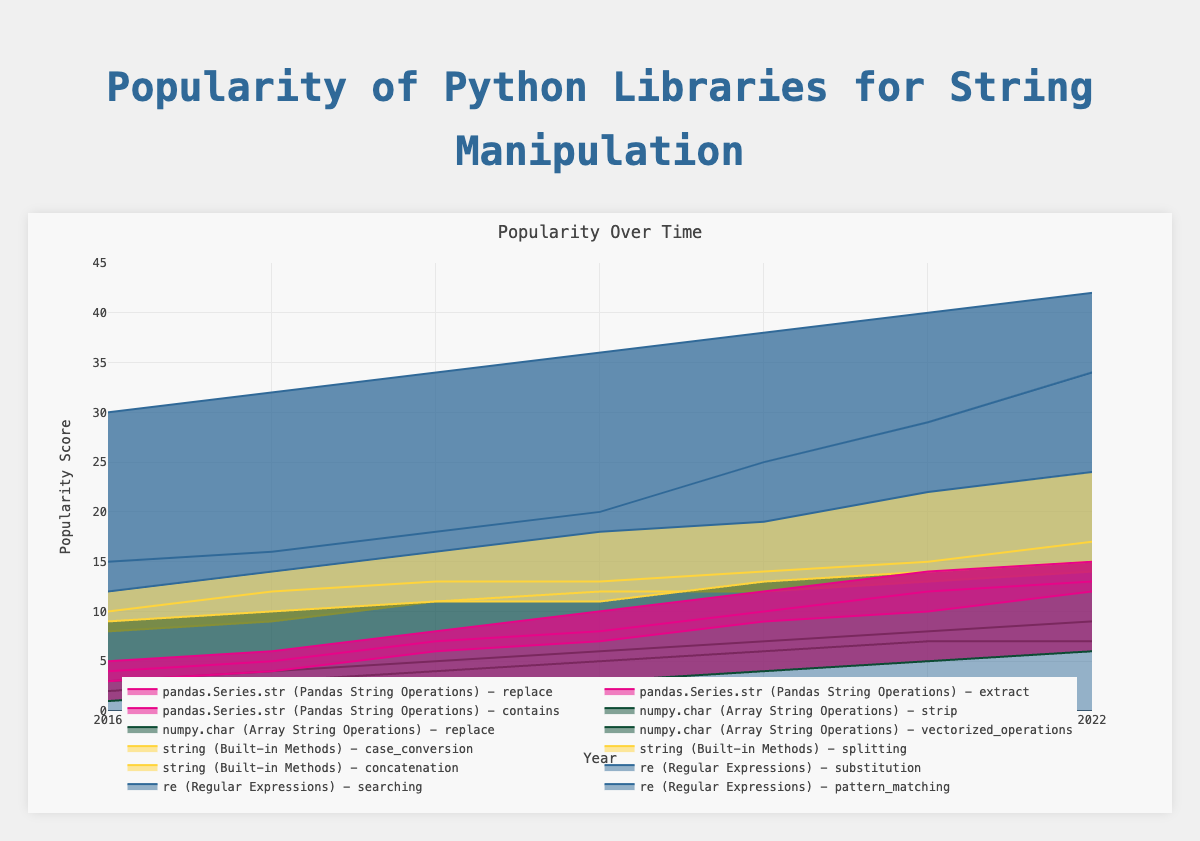What is the title of the chart? The title is prominently displayed at the top of the chart and reads "Popularity Over Time."
Answer: Popularity Over Time Which library function for 're (Regular Expressions)' has the highest popularity score in 2022? By examining the Y-axis values for 2022, we can see that 'pattern_matching' reaches a value of 42, which is higher than other 're (Regular Expressions)' functions.
Answer: pattern_matching What are the axis titles of the chart? The X-axis title is "Year" and the Y-axis title is "Popularity Score," as indicated below the respective axes.
Answer: "Year" and "Popularity Score" In which year did 'pandas.Series.str (Pandas String Operations) - extract' reach a popularity score of 10? By locating the line corresponding to 'pandas.Series.str - extract' and tracing it to the year where it reaches a score of 10, we determine that this occurs in 2020.
Answer: 2020 How much did the popularity score for 'string (Built-in Methods) - concatenation' increase from 2016 to 2022? The popularity score for 'concatenation' in 2016 is 10 and rises to 17 in 2022, resulting in an increase of 17 - 10 = 7.
Answer: 7 Compare the popularity of 'numpy.char - vectorized_operations' and 'pandas.Series.str - contains' in 2018. Which one is more popular and by how much? In 2018, 'numpy.char - vectorized_operations' has a score of 5, while 'pandas.Series.str - contains' has a score of 8. Therefore, 'contains' is more popular by 8 - 5 = 3.
Answer: pandas.Series.str - contains, by 3 How has the popularity of 're (Regular Expressions) - substitution' changed from 2019 to 2021? The score for 'substitution' in 2019 is 18, and it increases to 22 in 2021. This shows an increase of 22 - 18 = 4.
Answer: Increased by 4 Which function in 'string (Built-in Methods)' shows the least growth in popularity from 2019 to 2022? 'splitting' has scores of 12 in 2019 and 14 in 2022. The growth is 14 - 12 = 2, which is less than 'concatenation' (4) and 'case_conversion' (4).
Answer: splitting What is the average popularity score of 'numpy.char (Array String Operations) - replace' between 2016 and 2022? The scores for 'replace' from 2016 to 2022 are [2, 3, 4, 5, 6, 7, 7]. Summing them gives 34 and the average is 34 / 7 ≈ 4.86.
Answer: 4.86 Which libraries have functions that surpassed a popularity score of 20 in 2022? Examining the values for 2022, 're (Regular Expressions)' functions (pattern_matching: 42, searching: 34, substitution: 24) and 'pandas.Series.str (Pandas String Operations)' functions (contains: 15, extract: 13, replace: 12) surpass 20.
Answer: re (Regular Expressions) 